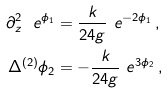Convert formula to latex. <formula><loc_0><loc_0><loc_500><loc_500>\partial ^ { 2 } _ { z } \ e ^ { \phi _ { 1 } } & = \frac { k } { 2 4 g } \ e ^ { - 2 \phi _ { 1 } } \, , \\ \Delta ^ { ( 2 ) } \phi _ { 2 } & = - \frac { k } { 2 4 g } \ e ^ { 3 \phi _ { 2 } } \, ,</formula> 